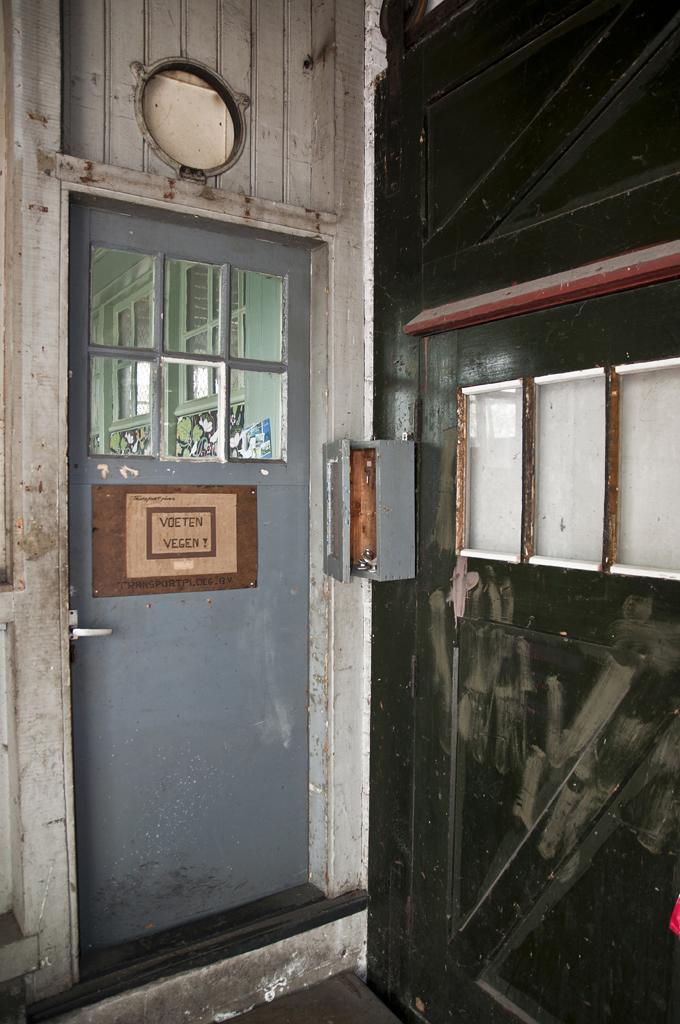Could you give a brief overview of what you see in this image? In this image I can see on the left side there is a door with glass, in the middle there is a box. On the right side it looks like there is white color frame with glass. 